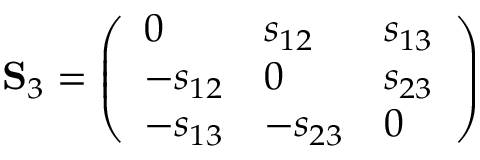<formula> <loc_0><loc_0><loc_500><loc_500>S _ { 3 } = \left ( \begin{array} { l l l } { 0 } & { s _ { 1 2 } } & { s _ { 1 3 } } \\ { - s _ { 1 2 } } & { 0 } & { s _ { 2 3 } } \\ { - s _ { 1 3 } } & { - s _ { 2 3 } } & { 0 } \end{array} \right )</formula> 